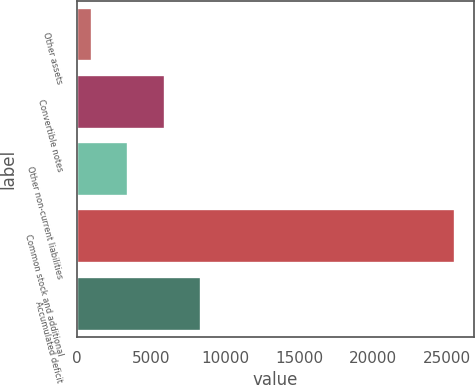Convert chart to OTSL. <chart><loc_0><loc_0><loc_500><loc_500><bar_chart><fcel>Other assets<fcel>Convertible notes<fcel>Other non-current liabilities<fcel>Common stock and additional<fcel>Accumulated deficit<nl><fcel>1016<fcel>5918.2<fcel>3467.1<fcel>25527<fcel>8369.3<nl></chart> 